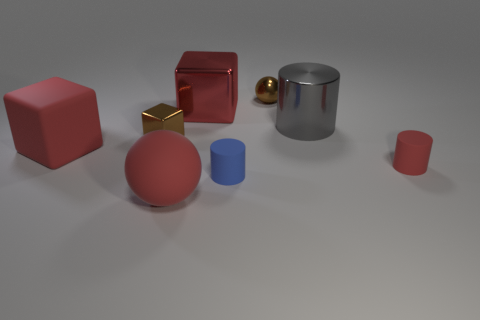This image seems to be digitally created. Can you describe clues that support this assumption? Certainly, there are a few telltale signs that this image could be a computer-generated rendering. First, the lighting has a soft uniformity that's rare in real-world scenes; shadows are present but lack the intensity and variation typically seen with natural light. Additionally, the objects' surfaces are flawless and exhibit perfectly smooth edges, reflecting light in ways that appear idealized. Lastly, the setting lacks context, such as a recognizable environment or surface texture, often a characteristic of digital compositions designed to highlight the objects themselves. 